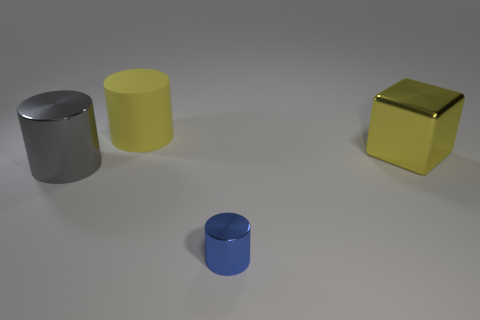Add 3 large gray metallic things. How many objects exist? 7 Subtract all cylinders. How many objects are left? 1 Add 3 tiny blue metallic objects. How many tiny blue metallic objects exist? 4 Subtract 0 green blocks. How many objects are left? 4 Subtract all green shiny objects. Subtract all big rubber things. How many objects are left? 3 Add 4 large yellow metallic blocks. How many large yellow metallic blocks are left? 5 